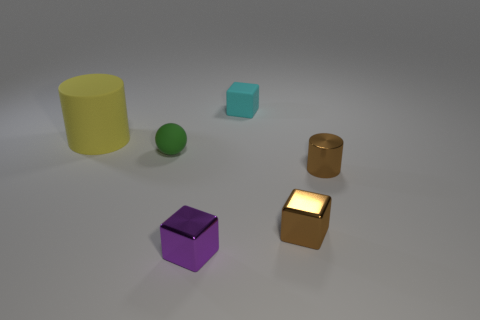Are there any patterns or consistencies among the objects in the image? While each object seems unique, there is a pattern in their arrangement; they are spaced out evenly across the surface. Additionally, with the exception of the golden cube, the objects share a consistency in their matte finish and lack of complex textures. 